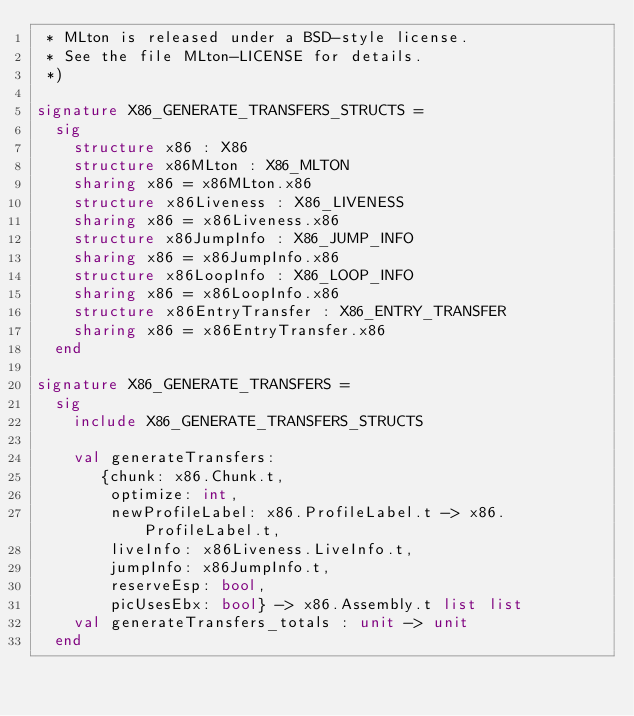Convert code to text. <code><loc_0><loc_0><loc_500><loc_500><_SML_> * MLton is released under a BSD-style license.
 * See the file MLton-LICENSE for details.
 *)

signature X86_GENERATE_TRANSFERS_STRUCTS =
  sig
    structure x86 : X86
    structure x86MLton : X86_MLTON
    sharing x86 = x86MLton.x86
    structure x86Liveness : X86_LIVENESS
    sharing x86 = x86Liveness.x86
    structure x86JumpInfo : X86_JUMP_INFO
    sharing x86 = x86JumpInfo.x86
    structure x86LoopInfo : X86_LOOP_INFO
    sharing x86 = x86LoopInfo.x86
    structure x86EntryTransfer : X86_ENTRY_TRANSFER
    sharing x86 = x86EntryTransfer.x86
  end

signature X86_GENERATE_TRANSFERS =
  sig
    include X86_GENERATE_TRANSFERS_STRUCTS

    val generateTransfers:
       {chunk: x86.Chunk.t,
        optimize: int,
        newProfileLabel: x86.ProfileLabel.t -> x86.ProfileLabel.t,
        liveInfo: x86Liveness.LiveInfo.t,
        jumpInfo: x86JumpInfo.t,
        reserveEsp: bool,
        picUsesEbx: bool} -> x86.Assembly.t list list
    val generateTransfers_totals : unit -> unit
  end
</code> 